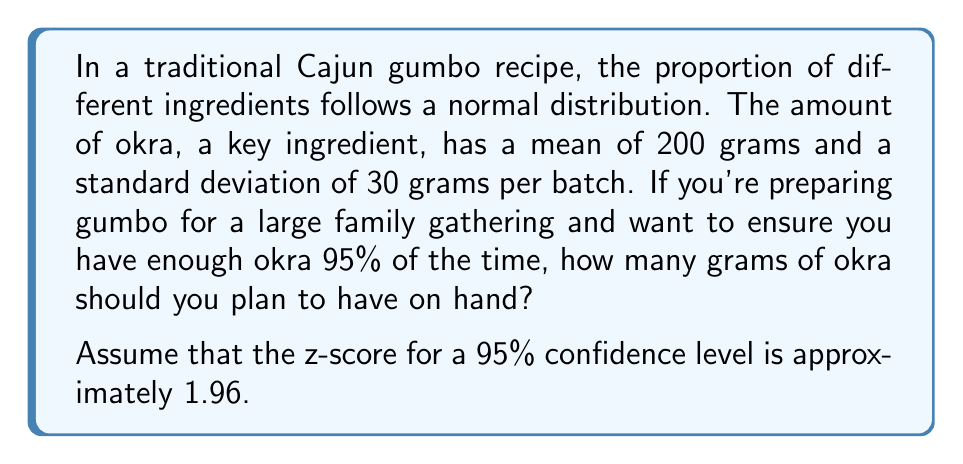Give your solution to this math problem. To solve this problem, we'll use the properties of the normal distribution and the concept of z-scores. Here's a step-by-step approach:

1. Identify the given information:
   - Mean (μ) = 200 grams
   - Standard deviation (σ) = 30 grams
   - Desired confidence level = 95%
   - Z-score for 95% confidence = 1.96

2. Use the formula for the upper bound of a confidence interval:
   $$ X = μ + (z * σ) $$
   Where:
   - X is the amount of okra needed
   - μ is the mean
   - z is the z-score
   - σ is the standard deviation

3. Substitute the values into the formula:
   $$ X = 200 + (1.96 * 30) $$

4. Calculate:
   $$ X = 200 + 58.8 $$
   $$ X = 258.8 $$

5. Round up to the nearest gram:
   X ≈ 259 grams

Therefore, to ensure you have enough okra 95% of the time, you should plan to have 259 grams on hand.
Answer: 259 grams 